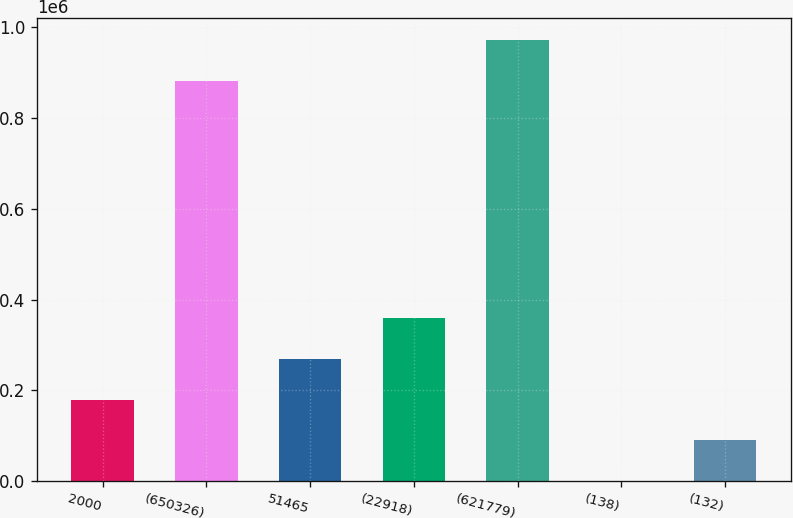Convert chart. <chart><loc_0><loc_0><loc_500><loc_500><bar_chart><fcel>2000<fcel>(650326)<fcel>51465<fcel>(22918)<fcel>(621779)<fcel>(138)<fcel>(132)<nl><fcel>179491<fcel>881650<fcel>269236<fcel>358981<fcel>971395<fcel>0.92<fcel>89746<nl></chart> 